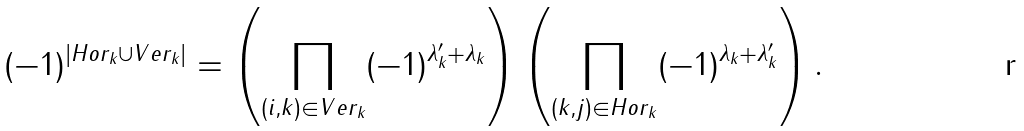Convert formula to latex. <formula><loc_0><loc_0><loc_500><loc_500>( - 1 ) ^ { | H o r _ { k } \cup V e r _ { k } | } = \left ( \prod _ { ( i , k ) \in V e r _ { k } } ( - 1 ) ^ { \lambda _ { k } ^ { \prime } + \lambda _ { k } } \right ) \left ( \prod _ { ( k , j ) \in H o r _ { k } } ( - 1 ) ^ { \lambda _ { k } + \lambda _ { k } ^ { \prime } } \right ) .</formula> 